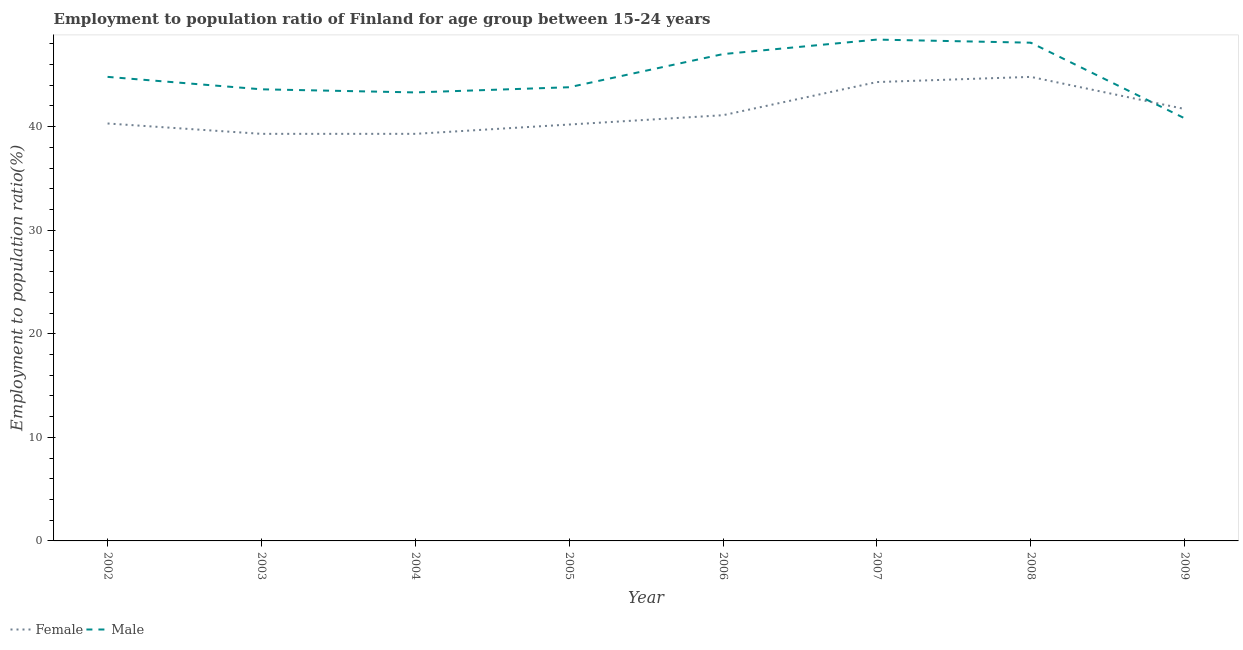How many different coloured lines are there?
Your response must be concise. 2. What is the employment to population ratio(male) in 2009?
Your answer should be compact. 40.8. Across all years, what is the maximum employment to population ratio(male)?
Your answer should be compact. 48.4. Across all years, what is the minimum employment to population ratio(male)?
Give a very brief answer. 40.8. What is the total employment to population ratio(female) in the graph?
Keep it short and to the point. 331. What is the difference between the employment to population ratio(female) in 2005 and that in 2009?
Provide a short and direct response. -1.5. What is the difference between the employment to population ratio(male) in 2009 and the employment to population ratio(female) in 2005?
Ensure brevity in your answer.  0.6. What is the average employment to population ratio(female) per year?
Provide a succinct answer. 41.37. In the year 2009, what is the difference between the employment to population ratio(female) and employment to population ratio(male)?
Your response must be concise. 0.9. What is the ratio of the employment to population ratio(male) in 2005 to that in 2009?
Provide a short and direct response. 1.07. Is the difference between the employment to population ratio(female) in 2006 and 2007 greater than the difference between the employment to population ratio(male) in 2006 and 2007?
Your answer should be compact. No. What is the difference between the highest and the lowest employment to population ratio(male)?
Give a very brief answer. 7.6. Does the employment to population ratio(female) monotonically increase over the years?
Ensure brevity in your answer.  No. Is the employment to population ratio(male) strictly less than the employment to population ratio(female) over the years?
Make the answer very short. No. How many years are there in the graph?
Give a very brief answer. 8. What is the difference between two consecutive major ticks on the Y-axis?
Offer a terse response. 10. Are the values on the major ticks of Y-axis written in scientific E-notation?
Make the answer very short. No. Where does the legend appear in the graph?
Ensure brevity in your answer.  Bottom left. What is the title of the graph?
Your answer should be very brief. Employment to population ratio of Finland for age group between 15-24 years. Does "Official creditors" appear as one of the legend labels in the graph?
Provide a succinct answer. No. What is the label or title of the X-axis?
Offer a very short reply. Year. What is the Employment to population ratio(%) in Female in 2002?
Offer a terse response. 40.3. What is the Employment to population ratio(%) of Male in 2002?
Keep it short and to the point. 44.8. What is the Employment to population ratio(%) of Female in 2003?
Your answer should be very brief. 39.3. What is the Employment to population ratio(%) of Male in 2003?
Provide a short and direct response. 43.6. What is the Employment to population ratio(%) of Female in 2004?
Keep it short and to the point. 39.3. What is the Employment to population ratio(%) of Male in 2004?
Ensure brevity in your answer.  43.3. What is the Employment to population ratio(%) of Female in 2005?
Provide a succinct answer. 40.2. What is the Employment to population ratio(%) in Male in 2005?
Your answer should be compact. 43.8. What is the Employment to population ratio(%) of Female in 2006?
Ensure brevity in your answer.  41.1. What is the Employment to population ratio(%) of Female in 2007?
Give a very brief answer. 44.3. What is the Employment to population ratio(%) in Male in 2007?
Keep it short and to the point. 48.4. What is the Employment to population ratio(%) in Female in 2008?
Make the answer very short. 44.8. What is the Employment to population ratio(%) in Male in 2008?
Your response must be concise. 48.1. What is the Employment to population ratio(%) of Female in 2009?
Offer a terse response. 41.7. What is the Employment to population ratio(%) in Male in 2009?
Ensure brevity in your answer.  40.8. Across all years, what is the maximum Employment to population ratio(%) of Female?
Your answer should be very brief. 44.8. Across all years, what is the maximum Employment to population ratio(%) in Male?
Give a very brief answer. 48.4. Across all years, what is the minimum Employment to population ratio(%) of Female?
Make the answer very short. 39.3. Across all years, what is the minimum Employment to population ratio(%) of Male?
Ensure brevity in your answer.  40.8. What is the total Employment to population ratio(%) of Female in the graph?
Your answer should be very brief. 331. What is the total Employment to population ratio(%) in Male in the graph?
Keep it short and to the point. 359.8. What is the difference between the Employment to population ratio(%) in Female in 2002 and that in 2004?
Your response must be concise. 1. What is the difference between the Employment to population ratio(%) in Female in 2002 and that in 2006?
Make the answer very short. -0.8. What is the difference between the Employment to population ratio(%) in Female in 2002 and that in 2007?
Offer a terse response. -4. What is the difference between the Employment to population ratio(%) of Male in 2002 and that in 2007?
Your answer should be very brief. -3.6. What is the difference between the Employment to population ratio(%) in Male in 2002 and that in 2008?
Give a very brief answer. -3.3. What is the difference between the Employment to population ratio(%) of Female in 2002 and that in 2009?
Your answer should be compact. -1.4. What is the difference between the Employment to population ratio(%) in Male in 2002 and that in 2009?
Offer a terse response. 4. What is the difference between the Employment to population ratio(%) in Male in 2003 and that in 2004?
Your answer should be compact. 0.3. What is the difference between the Employment to population ratio(%) in Female in 2003 and that in 2005?
Ensure brevity in your answer.  -0.9. What is the difference between the Employment to population ratio(%) of Male in 2003 and that in 2005?
Your answer should be very brief. -0.2. What is the difference between the Employment to population ratio(%) in Female in 2003 and that in 2008?
Your response must be concise. -5.5. What is the difference between the Employment to population ratio(%) of Male in 2003 and that in 2008?
Give a very brief answer. -4.5. What is the difference between the Employment to population ratio(%) in Female in 2003 and that in 2009?
Make the answer very short. -2.4. What is the difference between the Employment to population ratio(%) in Male in 2004 and that in 2005?
Make the answer very short. -0.5. What is the difference between the Employment to population ratio(%) in Male in 2004 and that in 2006?
Your response must be concise. -3.7. What is the difference between the Employment to population ratio(%) in Male in 2004 and that in 2007?
Provide a short and direct response. -5.1. What is the difference between the Employment to population ratio(%) in Female in 2004 and that in 2008?
Provide a succinct answer. -5.5. What is the difference between the Employment to population ratio(%) of Male in 2004 and that in 2008?
Your answer should be very brief. -4.8. What is the difference between the Employment to population ratio(%) in Female in 2005 and that in 2006?
Your answer should be compact. -0.9. What is the difference between the Employment to population ratio(%) of Female in 2006 and that in 2008?
Your answer should be very brief. -3.7. What is the difference between the Employment to population ratio(%) in Male in 2006 and that in 2008?
Offer a very short reply. -1.1. What is the difference between the Employment to population ratio(%) of Female in 2006 and that in 2009?
Your answer should be compact. -0.6. What is the difference between the Employment to population ratio(%) in Female in 2007 and that in 2008?
Keep it short and to the point. -0.5. What is the difference between the Employment to population ratio(%) of Female in 2002 and the Employment to population ratio(%) of Male in 2003?
Your answer should be very brief. -3.3. What is the difference between the Employment to population ratio(%) in Female in 2002 and the Employment to population ratio(%) in Male in 2005?
Provide a succinct answer. -3.5. What is the difference between the Employment to population ratio(%) in Female in 2002 and the Employment to population ratio(%) in Male in 2006?
Give a very brief answer. -6.7. What is the difference between the Employment to population ratio(%) of Female in 2002 and the Employment to population ratio(%) of Male in 2007?
Your answer should be very brief. -8.1. What is the difference between the Employment to population ratio(%) in Female in 2003 and the Employment to population ratio(%) in Male in 2005?
Offer a terse response. -4.5. What is the difference between the Employment to population ratio(%) in Female in 2003 and the Employment to population ratio(%) in Male in 2008?
Offer a terse response. -8.8. What is the difference between the Employment to population ratio(%) in Female in 2004 and the Employment to population ratio(%) in Male in 2006?
Your answer should be very brief. -7.7. What is the difference between the Employment to population ratio(%) of Female in 2004 and the Employment to population ratio(%) of Male in 2007?
Make the answer very short. -9.1. What is the difference between the Employment to population ratio(%) in Female in 2004 and the Employment to population ratio(%) in Male in 2008?
Your answer should be very brief. -8.8. What is the difference between the Employment to population ratio(%) in Female in 2005 and the Employment to population ratio(%) in Male in 2006?
Provide a short and direct response. -6.8. What is the difference between the Employment to population ratio(%) in Female in 2005 and the Employment to population ratio(%) in Male in 2007?
Offer a very short reply. -8.2. What is the difference between the Employment to population ratio(%) of Female in 2005 and the Employment to population ratio(%) of Male in 2009?
Your response must be concise. -0.6. What is the difference between the Employment to population ratio(%) of Female in 2006 and the Employment to population ratio(%) of Male in 2009?
Offer a terse response. 0.3. What is the difference between the Employment to population ratio(%) in Female in 2008 and the Employment to population ratio(%) in Male in 2009?
Your answer should be very brief. 4. What is the average Employment to population ratio(%) in Female per year?
Offer a very short reply. 41.38. What is the average Employment to population ratio(%) in Male per year?
Your response must be concise. 44.98. In the year 2003, what is the difference between the Employment to population ratio(%) of Female and Employment to population ratio(%) of Male?
Offer a very short reply. -4.3. In the year 2006, what is the difference between the Employment to population ratio(%) of Female and Employment to population ratio(%) of Male?
Your answer should be very brief. -5.9. In the year 2008, what is the difference between the Employment to population ratio(%) of Female and Employment to population ratio(%) of Male?
Ensure brevity in your answer.  -3.3. What is the ratio of the Employment to population ratio(%) in Female in 2002 to that in 2003?
Offer a terse response. 1.03. What is the ratio of the Employment to population ratio(%) in Male in 2002 to that in 2003?
Offer a terse response. 1.03. What is the ratio of the Employment to population ratio(%) of Female in 2002 to that in 2004?
Offer a terse response. 1.03. What is the ratio of the Employment to population ratio(%) of Male in 2002 to that in 2004?
Your answer should be compact. 1.03. What is the ratio of the Employment to population ratio(%) of Female in 2002 to that in 2005?
Your answer should be compact. 1. What is the ratio of the Employment to population ratio(%) of Male in 2002 to that in 2005?
Offer a terse response. 1.02. What is the ratio of the Employment to population ratio(%) of Female in 2002 to that in 2006?
Your response must be concise. 0.98. What is the ratio of the Employment to population ratio(%) of Male in 2002 to that in 2006?
Ensure brevity in your answer.  0.95. What is the ratio of the Employment to population ratio(%) of Female in 2002 to that in 2007?
Make the answer very short. 0.91. What is the ratio of the Employment to population ratio(%) of Male in 2002 to that in 2007?
Give a very brief answer. 0.93. What is the ratio of the Employment to population ratio(%) of Female in 2002 to that in 2008?
Provide a short and direct response. 0.9. What is the ratio of the Employment to population ratio(%) in Male in 2002 to that in 2008?
Offer a terse response. 0.93. What is the ratio of the Employment to population ratio(%) of Female in 2002 to that in 2009?
Ensure brevity in your answer.  0.97. What is the ratio of the Employment to population ratio(%) in Male in 2002 to that in 2009?
Your answer should be very brief. 1.1. What is the ratio of the Employment to population ratio(%) of Female in 2003 to that in 2005?
Your answer should be compact. 0.98. What is the ratio of the Employment to population ratio(%) of Male in 2003 to that in 2005?
Keep it short and to the point. 1. What is the ratio of the Employment to population ratio(%) in Female in 2003 to that in 2006?
Make the answer very short. 0.96. What is the ratio of the Employment to population ratio(%) in Male in 2003 to that in 2006?
Your response must be concise. 0.93. What is the ratio of the Employment to population ratio(%) in Female in 2003 to that in 2007?
Make the answer very short. 0.89. What is the ratio of the Employment to population ratio(%) of Male in 2003 to that in 2007?
Keep it short and to the point. 0.9. What is the ratio of the Employment to population ratio(%) of Female in 2003 to that in 2008?
Make the answer very short. 0.88. What is the ratio of the Employment to population ratio(%) in Male in 2003 to that in 2008?
Provide a short and direct response. 0.91. What is the ratio of the Employment to population ratio(%) of Female in 2003 to that in 2009?
Ensure brevity in your answer.  0.94. What is the ratio of the Employment to population ratio(%) in Male in 2003 to that in 2009?
Ensure brevity in your answer.  1.07. What is the ratio of the Employment to population ratio(%) in Female in 2004 to that in 2005?
Your response must be concise. 0.98. What is the ratio of the Employment to population ratio(%) of Male in 2004 to that in 2005?
Keep it short and to the point. 0.99. What is the ratio of the Employment to population ratio(%) in Female in 2004 to that in 2006?
Provide a succinct answer. 0.96. What is the ratio of the Employment to population ratio(%) in Male in 2004 to that in 2006?
Keep it short and to the point. 0.92. What is the ratio of the Employment to population ratio(%) of Female in 2004 to that in 2007?
Your answer should be compact. 0.89. What is the ratio of the Employment to population ratio(%) of Male in 2004 to that in 2007?
Provide a short and direct response. 0.89. What is the ratio of the Employment to population ratio(%) of Female in 2004 to that in 2008?
Offer a terse response. 0.88. What is the ratio of the Employment to population ratio(%) of Male in 2004 to that in 2008?
Make the answer very short. 0.9. What is the ratio of the Employment to population ratio(%) of Female in 2004 to that in 2009?
Your response must be concise. 0.94. What is the ratio of the Employment to population ratio(%) in Male in 2004 to that in 2009?
Offer a terse response. 1.06. What is the ratio of the Employment to population ratio(%) in Female in 2005 to that in 2006?
Your answer should be compact. 0.98. What is the ratio of the Employment to population ratio(%) of Male in 2005 to that in 2006?
Provide a succinct answer. 0.93. What is the ratio of the Employment to population ratio(%) of Female in 2005 to that in 2007?
Make the answer very short. 0.91. What is the ratio of the Employment to population ratio(%) of Male in 2005 to that in 2007?
Your answer should be very brief. 0.91. What is the ratio of the Employment to population ratio(%) of Female in 2005 to that in 2008?
Provide a short and direct response. 0.9. What is the ratio of the Employment to population ratio(%) in Male in 2005 to that in 2008?
Provide a succinct answer. 0.91. What is the ratio of the Employment to population ratio(%) in Male in 2005 to that in 2009?
Offer a terse response. 1.07. What is the ratio of the Employment to population ratio(%) of Female in 2006 to that in 2007?
Keep it short and to the point. 0.93. What is the ratio of the Employment to population ratio(%) in Male in 2006 to that in 2007?
Your answer should be compact. 0.97. What is the ratio of the Employment to population ratio(%) in Female in 2006 to that in 2008?
Provide a succinct answer. 0.92. What is the ratio of the Employment to population ratio(%) of Male in 2006 to that in 2008?
Ensure brevity in your answer.  0.98. What is the ratio of the Employment to population ratio(%) in Female in 2006 to that in 2009?
Your response must be concise. 0.99. What is the ratio of the Employment to population ratio(%) in Male in 2006 to that in 2009?
Give a very brief answer. 1.15. What is the ratio of the Employment to population ratio(%) of Female in 2007 to that in 2008?
Keep it short and to the point. 0.99. What is the ratio of the Employment to population ratio(%) of Male in 2007 to that in 2008?
Your answer should be very brief. 1.01. What is the ratio of the Employment to population ratio(%) of Female in 2007 to that in 2009?
Ensure brevity in your answer.  1.06. What is the ratio of the Employment to population ratio(%) in Male in 2007 to that in 2009?
Offer a terse response. 1.19. What is the ratio of the Employment to population ratio(%) of Female in 2008 to that in 2009?
Make the answer very short. 1.07. What is the ratio of the Employment to population ratio(%) in Male in 2008 to that in 2009?
Offer a very short reply. 1.18. What is the difference between the highest and the second highest Employment to population ratio(%) of Female?
Offer a very short reply. 0.5. What is the difference between the highest and the lowest Employment to population ratio(%) of Female?
Your response must be concise. 5.5. 